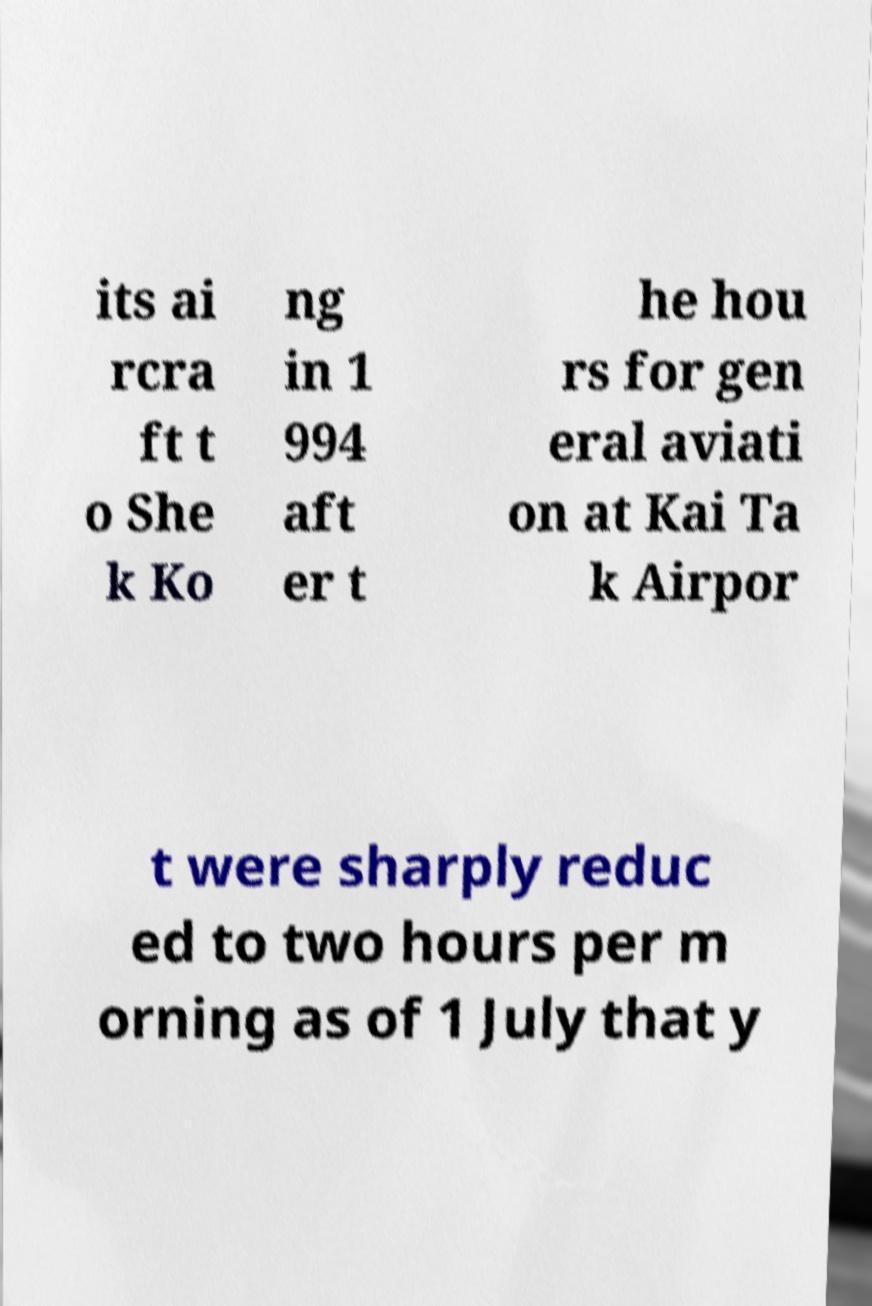Can you accurately transcribe the text from the provided image for me? its ai rcra ft t o She k Ko ng in 1 994 aft er t he hou rs for gen eral aviati on at Kai Ta k Airpor t were sharply reduc ed to two hours per m orning as of 1 July that y 